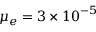Convert formula to latex. <formula><loc_0><loc_0><loc_500><loc_500>\mu _ { e } = 3 \times { 1 0 } ^ { - 5 }</formula> 